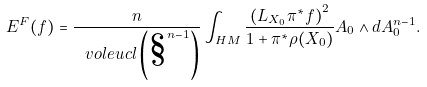<formula> <loc_0><loc_0><loc_500><loc_500>E ^ { F } ( f ) = \frac { n } { \ v o l e u c l \left ( \S ^ { n - 1 } \right ) } \int _ { H M } \frac { \left ( L _ { X _ { 0 } } \pi ^ { \ast } f \right ) ^ { 2 } } { 1 + \pi ^ { \ast } \rho ( X _ { 0 } ) } A _ { 0 } \wedge d A _ { 0 } ^ { n - 1 } .</formula> 